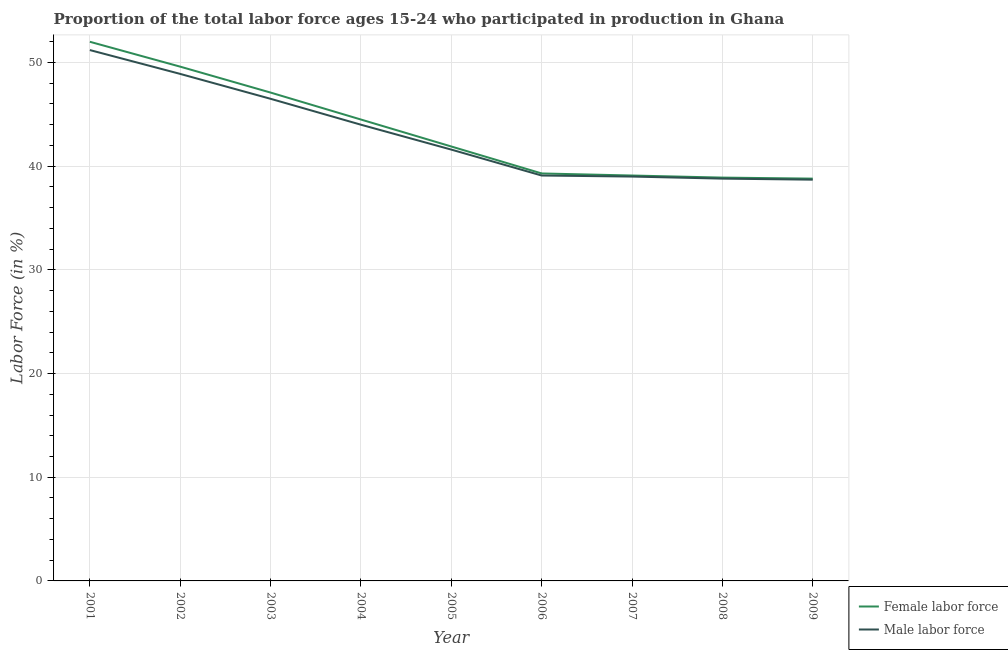Does the line corresponding to percentage of female labor force intersect with the line corresponding to percentage of male labour force?
Offer a terse response. No. What is the percentage of male labour force in 2008?
Your answer should be compact. 38.8. Across all years, what is the maximum percentage of male labour force?
Provide a short and direct response. 51.2. Across all years, what is the minimum percentage of male labour force?
Ensure brevity in your answer.  38.7. In which year was the percentage of female labor force maximum?
Offer a terse response. 2001. What is the total percentage of male labour force in the graph?
Provide a short and direct response. 387.8. What is the difference between the percentage of male labour force in 2003 and that in 2005?
Ensure brevity in your answer.  4.9. What is the difference between the percentage of female labor force in 2008 and the percentage of male labour force in 2002?
Your answer should be compact. -10. What is the average percentage of female labor force per year?
Ensure brevity in your answer.  43.47. In the year 2005, what is the difference between the percentage of female labor force and percentage of male labour force?
Keep it short and to the point. 0.3. In how many years, is the percentage of female labor force greater than 28 %?
Ensure brevity in your answer.  9. What is the ratio of the percentage of female labor force in 2007 to that in 2008?
Give a very brief answer. 1.01. Is the difference between the percentage of female labor force in 2001 and 2004 greater than the difference between the percentage of male labour force in 2001 and 2004?
Your response must be concise. Yes. What is the difference between the highest and the second highest percentage of female labor force?
Ensure brevity in your answer.  2.4. What is the difference between the highest and the lowest percentage of female labor force?
Your answer should be compact. 13.2. In how many years, is the percentage of male labour force greater than the average percentage of male labour force taken over all years?
Make the answer very short. 4. Is the sum of the percentage of male labour force in 2001 and 2004 greater than the maximum percentage of female labor force across all years?
Offer a terse response. Yes. Does the percentage of male labour force monotonically increase over the years?
Your answer should be very brief. No. Is the percentage of female labor force strictly greater than the percentage of male labour force over the years?
Keep it short and to the point. Yes. Is the percentage of female labor force strictly less than the percentage of male labour force over the years?
Make the answer very short. No. What is the difference between two consecutive major ticks on the Y-axis?
Your answer should be compact. 10. Does the graph contain grids?
Your answer should be compact. Yes. How are the legend labels stacked?
Offer a terse response. Vertical. What is the title of the graph?
Provide a short and direct response. Proportion of the total labor force ages 15-24 who participated in production in Ghana. Does "Death rate" appear as one of the legend labels in the graph?
Provide a succinct answer. No. What is the label or title of the X-axis?
Provide a succinct answer. Year. What is the label or title of the Y-axis?
Your response must be concise. Labor Force (in %). What is the Labor Force (in %) in Male labor force in 2001?
Ensure brevity in your answer.  51.2. What is the Labor Force (in %) of Female labor force in 2002?
Offer a terse response. 49.6. What is the Labor Force (in %) in Male labor force in 2002?
Give a very brief answer. 48.9. What is the Labor Force (in %) of Female labor force in 2003?
Offer a very short reply. 47.1. What is the Labor Force (in %) of Male labor force in 2003?
Provide a succinct answer. 46.5. What is the Labor Force (in %) in Female labor force in 2004?
Your response must be concise. 44.5. What is the Labor Force (in %) of Female labor force in 2005?
Offer a terse response. 41.9. What is the Labor Force (in %) in Male labor force in 2005?
Your answer should be very brief. 41.6. What is the Labor Force (in %) in Female labor force in 2006?
Your answer should be compact. 39.3. What is the Labor Force (in %) of Male labor force in 2006?
Your answer should be compact. 39.1. What is the Labor Force (in %) of Female labor force in 2007?
Provide a short and direct response. 39.1. What is the Labor Force (in %) of Male labor force in 2007?
Make the answer very short. 39. What is the Labor Force (in %) of Female labor force in 2008?
Ensure brevity in your answer.  38.9. What is the Labor Force (in %) in Male labor force in 2008?
Your answer should be very brief. 38.8. What is the Labor Force (in %) in Female labor force in 2009?
Give a very brief answer. 38.8. What is the Labor Force (in %) of Male labor force in 2009?
Provide a succinct answer. 38.7. Across all years, what is the maximum Labor Force (in %) of Female labor force?
Offer a terse response. 52. Across all years, what is the maximum Labor Force (in %) in Male labor force?
Make the answer very short. 51.2. Across all years, what is the minimum Labor Force (in %) of Female labor force?
Provide a short and direct response. 38.8. Across all years, what is the minimum Labor Force (in %) of Male labor force?
Your answer should be compact. 38.7. What is the total Labor Force (in %) of Female labor force in the graph?
Provide a short and direct response. 391.2. What is the total Labor Force (in %) in Male labor force in the graph?
Keep it short and to the point. 387.8. What is the difference between the Labor Force (in %) of Female labor force in 2001 and that in 2004?
Ensure brevity in your answer.  7.5. What is the difference between the Labor Force (in %) in Female labor force in 2001 and that in 2005?
Make the answer very short. 10.1. What is the difference between the Labor Force (in %) in Female labor force in 2001 and that in 2008?
Give a very brief answer. 13.1. What is the difference between the Labor Force (in %) in Male labor force in 2001 and that in 2008?
Provide a short and direct response. 12.4. What is the difference between the Labor Force (in %) of Male labor force in 2001 and that in 2009?
Provide a short and direct response. 12.5. What is the difference between the Labor Force (in %) in Female labor force in 2002 and that in 2003?
Provide a succinct answer. 2.5. What is the difference between the Labor Force (in %) of Female labor force in 2002 and that in 2004?
Your answer should be compact. 5.1. What is the difference between the Labor Force (in %) in Male labor force in 2002 and that in 2005?
Provide a succinct answer. 7.3. What is the difference between the Labor Force (in %) in Male labor force in 2002 and that in 2006?
Your answer should be very brief. 9.8. What is the difference between the Labor Force (in %) of Female labor force in 2002 and that in 2007?
Ensure brevity in your answer.  10.5. What is the difference between the Labor Force (in %) in Male labor force in 2002 and that in 2008?
Make the answer very short. 10.1. What is the difference between the Labor Force (in %) of Female labor force in 2003 and that in 2005?
Provide a succinct answer. 5.2. What is the difference between the Labor Force (in %) in Male labor force in 2003 and that in 2005?
Offer a very short reply. 4.9. What is the difference between the Labor Force (in %) in Male labor force in 2003 and that in 2006?
Your answer should be very brief. 7.4. What is the difference between the Labor Force (in %) of Female labor force in 2003 and that in 2008?
Provide a short and direct response. 8.2. What is the difference between the Labor Force (in %) of Male labor force in 2003 and that in 2008?
Provide a succinct answer. 7.7. What is the difference between the Labor Force (in %) of Female labor force in 2004 and that in 2005?
Make the answer very short. 2.6. What is the difference between the Labor Force (in %) in Male labor force in 2004 and that in 2007?
Your response must be concise. 5. What is the difference between the Labor Force (in %) in Female labor force in 2004 and that in 2008?
Offer a terse response. 5.6. What is the difference between the Labor Force (in %) of Female labor force in 2004 and that in 2009?
Ensure brevity in your answer.  5.7. What is the difference between the Labor Force (in %) of Female labor force in 2005 and that in 2006?
Ensure brevity in your answer.  2.6. What is the difference between the Labor Force (in %) of Male labor force in 2005 and that in 2006?
Give a very brief answer. 2.5. What is the difference between the Labor Force (in %) of Female labor force in 2005 and that in 2007?
Your response must be concise. 2.8. What is the difference between the Labor Force (in %) in Female labor force in 2005 and that in 2008?
Offer a very short reply. 3. What is the difference between the Labor Force (in %) of Female labor force in 2005 and that in 2009?
Keep it short and to the point. 3.1. What is the difference between the Labor Force (in %) in Female labor force in 2006 and that in 2007?
Your response must be concise. 0.2. What is the difference between the Labor Force (in %) of Male labor force in 2006 and that in 2008?
Offer a terse response. 0.3. What is the difference between the Labor Force (in %) in Female labor force in 2006 and that in 2009?
Provide a short and direct response. 0.5. What is the difference between the Labor Force (in %) of Female labor force in 2007 and that in 2008?
Your answer should be very brief. 0.2. What is the difference between the Labor Force (in %) of Female labor force in 2007 and that in 2009?
Make the answer very short. 0.3. What is the difference between the Labor Force (in %) of Female labor force in 2008 and that in 2009?
Keep it short and to the point. 0.1. What is the difference between the Labor Force (in %) in Female labor force in 2001 and the Labor Force (in %) in Male labor force in 2002?
Your answer should be very brief. 3.1. What is the difference between the Labor Force (in %) in Female labor force in 2001 and the Labor Force (in %) in Male labor force in 2004?
Provide a short and direct response. 8. What is the difference between the Labor Force (in %) in Female labor force in 2001 and the Labor Force (in %) in Male labor force in 2006?
Your response must be concise. 12.9. What is the difference between the Labor Force (in %) of Female labor force in 2001 and the Labor Force (in %) of Male labor force in 2007?
Your answer should be very brief. 13. What is the difference between the Labor Force (in %) in Female labor force in 2001 and the Labor Force (in %) in Male labor force in 2008?
Your answer should be compact. 13.2. What is the difference between the Labor Force (in %) of Female labor force in 2002 and the Labor Force (in %) of Male labor force in 2004?
Offer a terse response. 5.6. What is the difference between the Labor Force (in %) of Female labor force in 2002 and the Labor Force (in %) of Male labor force in 2005?
Offer a terse response. 8. What is the difference between the Labor Force (in %) in Female labor force in 2002 and the Labor Force (in %) in Male labor force in 2006?
Make the answer very short. 10.5. What is the difference between the Labor Force (in %) of Female labor force in 2003 and the Labor Force (in %) of Male labor force in 2007?
Your response must be concise. 8.1. What is the difference between the Labor Force (in %) in Female labor force in 2003 and the Labor Force (in %) in Male labor force in 2008?
Keep it short and to the point. 8.3. What is the difference between the Labor Force (in %) of Female labor force in 2004 and the Labor Force (in %) of Male labor force in 2005?
Provide a short and direct response. 2.9. What is the difference between the Labor Force (in %) in Female labor force in 2004 and the Labor Force (in %) in Male labor force in 2006?
Offer a terse response. 5.4. What is the difference between the Labor Force (in %) in Female labor force in 2004 and the Labor Force (in %) in Male labor force in 2007?
Provide a short and direct response. 5.5. What is the difference between the Labor Force (in %) in Female labor force in 2004 and the Labor Force (in %) in Male labor force in 2009?
Your response must be concise. 5.8. What is the difference between the Labor Force (in %) of Female labor force in 2005 and the Labor Force (in %) of Male labor force in 2006?
Provide a short and direct response. 2.8. What is the difference between the Labor Force (in %) of Female labor force in 2005 and the Labor Force (in %) of Male labor force in 2007?
Provide a succinct answer. 2.9. What is the difference between the Labor Force (in %) of Female labor force in 2006 and the Labor Force (in %) of Male labor force in 2008?
Offer a terse response. 0.5. What is the difference between the Labor Force (in %) of Female labor force in 2007 and the Labor Force (in %) of Male labor force in 2008?
Your response must be concise. 0.3. What is the average Labor Force (in %) of Female labor force per year?
Your response must be concise. 43.47. What is the average Labor Force (in %) of Male labor force per year?
Ensure brevity in your answer.  43.09. In the year 2002, what is the difference between the Labor Force (in %) of Female labor force and Labor Force (in %) of Male labor force?
Ensure brevity in your answer.  0.7. In the year 2003, what is the difference between the Labor Force (in %) in Female labor force and Labor Force (in %) in Male labor force?
Ensure brevity in your answer.  0.6. In the year 2008, what is the difference between the Labor Force (in %) in Female labor force and Labor Force (in %) in Male labor force?
Give a very brief answer. 0.1. In the year 2009, what is the difference between the Labor Force (in %) in Female labor force and Labor Force (in %) in Male labor force?
Your answer should be very brief. 0.1. What is the ratio of the Labor Force (in %) in Female labor force in 2001 to that in 2002?
Provide a succinct answer. 1.05. What is the ratio of the Labor Force (in %) in Male labor force in 2001 to that in 2002?
Your response must be concise. 1.05. What is the ratio of the Labor Force (in %) in Female labor force in 2001 to that in 2003?
Offer a terse response. 1.1. What is the ratio of the Labor Force (in %) of Male labor force in 2001 to that in 2003?
Give a very brief answer. 1.1. What is the ratio of the Labor Force (in %) in Female labor force in 2001 to that in 2004?
Offer a very short reply. 1.17. What is the ratio of the Labor Force (in %) in Male labor force in 2001 to that in 2004?
Ensure brevity in your answer.  1.16. What is the ratio of the Labor Force (in %) of Female labor force in 2001 to that in 2005?
Your answer should be compact. 1.24. What is the ratio of the Labor Force (in %) of Male labor force in 2001 to that in 2005?
Keep it short and to the point. 1.23. What is the ratio of the Labor Force (in %) in Female labor force in 2001 to that in 2006?
Your response must be concise. 1.32. What is the ratio of the Labor Force (in %) in Male labor force in 2001 to that in 2006?
Offer a very short reply. 1.31. What is the ratio of the Labor Force (in %) of Female labor force in 2001 to that in 2007?
Keep it short and to the point. 1.33. What is the ratio of the Labor Force (in %) in Male labor force in 2001 to that in 2007?
Your answer should be very brief. 1.31. What is the ratio of the Labor Force (in %) in Female labor force in 2001 to that in 2008?
Your response must be concise. 1.34. What is the ratio of the Labor Force (in %) of Male labor force in 2001 to that in 2008?
Give a very brief answer. 1.32. What is the ratio of the Labor Force (in %) of Female labor force in 2001 to that in 2009?
Provide a succinct answer. 1.34. What is the ratio of the Labor Force (in %) of Male labor force in 2001 to that in 2009?
Offer a very short reply. 1.32. What is the ratio of the Labor Force (in %) of Female labor force in 2002 to that in 2003?
Keep it short and to the point. 1.05. What is the ratio of the Labor Force (in %) of Male labor force in 2002 to that in 2003?
Ensure brevity in your answer.  1.05. What is the ratio of the Labor Force (in %) in Female labor force in 2002 to that in 2004?
Keep it short and to the point. 1.11. What is the ratio of the Labor Force (in %) in Male labor force in 2002 to that in 2004?
Make the answer very short. 1.11. What is the ratio of the Labor Force (in %) of Female labor force in 2002 to that in 2005?
Give a very brief answer. 1.18. What is the ratio of the Labor Force (in %) of Male labor force in 2002 to that in 2005?
Make the answer very short. 1.18. What is the ratio of the Labor Force (in %) of Female labor force in 2002 to that in 2006?
Offer a very short reply. 1.26. What is the ratio of the Labor Force (in %) in Male labor force in 2002 to that in 2006?
Offer a very short reply. 1.25. What is the ratio of the Labor Force (in %) of Female labor force in 2002 to that in 2007?
Give a very brief answer. 1.27. What is the ratio of the Labor Force (in %) in Male labor force in 2002 to that in 2007?
Make the answer very short. 1.25. What is the ratio of the Labor Force (in %) of Female labor force in 2002 to that in 2008?
Offer a very short reply. 1.28. What is the ratio of the Labor Force (in %) in Male labor force in 2002 to that in 2008?
Give a very brief answer. 1.26. What is the ratio of the Labor Force (in %) of Female labor force in 2002 to that in 2009?
Provide a succinct answer. 1.28. What is the ratio of the Labor Force (in %) of Male labor force in 2002 to that in 2009?
Make the answer very short. 1.26. What is the ratio of the Labor Force (in %) of Female labor force in 2003 to that in 2004?
Keep it short and to the point. 1.06. What is the ratio of the Labor Force (in %) of Male labor force in 2003 to that in 2004?
Keep it short and to the point. 1.06. What is the ratio of the Labor Force (in %) of Female labor force in 2003 to that in 2005?
Provide a succinct answer. 1.12. What is the ratio of the Labor Force (in %) of Male labor force in 2003 to that in 2005?
Your answer should be compact. 1.12. What is the ratio of the Labor Force (in %) in Female labor force in 2003 to that in 2006?
Make the answer very short. 1.2. What is the ratio of the Labor Force (in %) of Male labor force in 2003 to that in 2006?
Ensure brevity in your answer.  1.19. What is the ratio of the Labor Force (in %) of Female labor force in 2003 to that in 2007?
Offer a terse response. 1.2. What is the ratio of the Labor Force (in %) of Male labor force in 2003 to that in 2007?
Your answer should be very brief. 1.19. What is the ratio of the Labor Force (in %) in Female labor force in 2003 to that in 2008?
Give a very brief answer. 1.21. What is the ratio of the Labor Force (in %) of Male labor force in 2003 to that in 2008?
Offer a very short reply. 1.2. What is the ratio of the Labor Force (in %) of Female labor force in 2003 to that in 2009?
Provide a succinct answer. 1.21. What is the ratio of the Labor Force (in %) in Male labor force in 2003 to that in 2009?
Your answer should be compact. 1.2. What is the ratio of the Labor Force (in %) of Female labor force in 2004 to that in 2005?
Your answer should be very brief. 1.06. What is the ratio of the Labor Force (in %) of Male labor force in 2004 to that in 2005?
Provide a short and direct response. 1.06. What is the ratio of the Labor Force (in %) in Female labor force in 2004 to that in 2006?
Keep it short and to the point. 1.13. What is the ratio of the Labor Force (in %) of Male labor force in 2004 to that in 2006?
Your answer should be compact. 1.13. What is the ratio of the Labor Force (in %) of Female labor force in 2004 to that in 2007?
Your answer should be compact. 1.14. What is the ratio of the Labor Force (in %) of Male labor force in 2004 to that in 2007?
Your response must be concise. 1.13. What is the ratio of the Labor Force (in %) of Female labor force in 2004 to that in 2008?
Offer a very short reply. 1.14. What is the ratio of the Labor Force (in %) of Male labor force in 2004 to that in 2008?
Ensure brevity in your answer.  1.13. What is the ratio of the Labor Force (in %) in Female labor force in 2004 to that in 2009?
Offer a very short reply. 1.15. What is the ratio of the Labor Force (in %) of Male labor force in 2004 to that in 2009?
Provide a short and direct response. 1.14. What is the ratio of the Labor Force (in %) in Female labor force in 2005 to that in 2006?
Your response must be concise. 1.07. What is the ratio of the Labor Force (in %) in Male labor force in 2005 to that in 2006?
Give a very brief answer. 1.06. What is the ratio of the Labor Force (in %) in Female labor force in 2005 to that in 2007?
Offer a terse response. 1.07. What is the ratio of the Labor Force (in %) in Male labor force in 2005 to that in 2007?
Your response must be concise. 1.07. What is the ratio of the Labor Force (in %) of Female labor force in 2005 to that in 2008?
Your answer should be very brief. 1.08. What is the ratio of the Labor Force (in %) in Male labor force in 2005 to that in 2008?
Your answer should be very brief. 1.07. What is the ratio of the Labor Force (in %) of Female labor force in 2005 to that in 2009?
Give a very brief answer. 1.08. What is the ratio of the Labor Force (in %) in Male labor force in 2005 to that in 2009?
Make the answer very short. 1.07. What is the ratio of the Labor Force (in %) of Female labor force in 2006 to that in 2007?
Offer a terse response. 1.01. What is the ratio of the Labor Force (in %) in Female labor force in 2006 to that in 2008?
Offer a very short reply. 1.01. What is the ratio of the Labor Force (in %) in Male labor force in 2006 to that in 2008?
Offer a very short reply. 1.01. What is the ratio of the Labor Force (in %) in Female labor force in 2006 to that in 2009?
Ensure brevity in your answer.  1.01. What is the ratio of the Labor Force (in %) in Male labor force in 2006 to that in 2009?
Give a very brief answer. 1.01. What is the ratio of the Labor Force (in %) in Male labor force in 2007 to that in 2008?
Make the answer very short. 1.01. What is the ratio of the Labor Force (in %) in Female labor force in 2007 to that in 2009?
Your answer should be compact. 1.01. What is the ratio of the Labor Force (in %) in Male labor force in 2007 to that in 2009?
Give a very brief answer. 1.01. What is the ratio of the Labor Force (in %) of Female labor force in 2008 to that in 2009?
Make the answer very short. 1. What is the difference between the highest and the second highest Labor Force (in %) of Female labor force?
Your answer should be very brief. 2.4. 